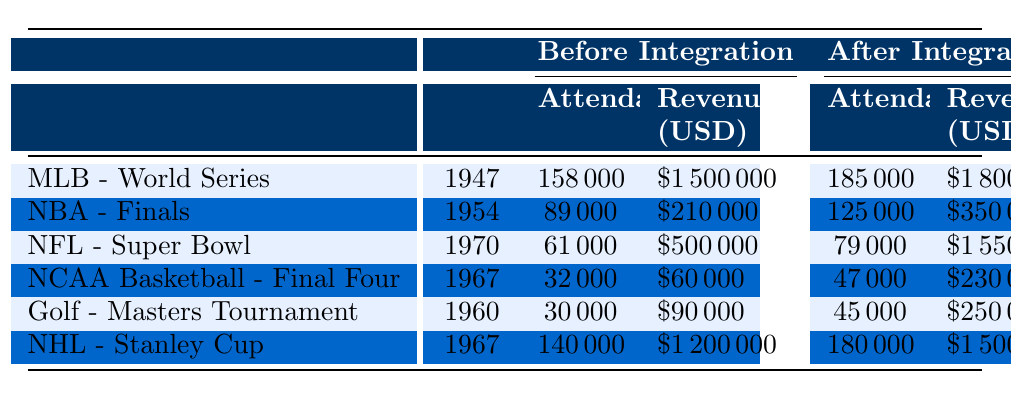What was the attendance at the MLB World Series in 1947? According to the table, the attendance at the MLB World Series in 1947 was listed under the "Before Integration" section, which shows a value of 158,000.
Answer: 158,000 How much revenue did the NBA Finals generate in 1954? The table indicates the revenue for the NBA Finals in 1954 under the "Before Integration" column, which is $210,000.
Answer: $210,000 Which sporting event had the highest attendance after integration? The table shows the attendance after integration for each event. The highest figure is found in the NHL Stanley Cup, with 180,000 attendees.
Answer: NHL Stanley Cup What was the difference in attendance for the NFL Super Bowl before and after integration? For the NFL Super Bowl, attendance before integration was 61,000 and after integration was 79,000. The difference is calculated as 79,000 - 61,000 = 18,000.
Answer: 18,000 Did NCAA Basketball - Final Four have an increase in revenue after integration? The revenue increased from $60,000 before integration to $230,000 after integration, so yes, there was an increase.
Answer: Yes What are the average attendances before and after integration across all events? Before integration: (158,000 + 89,000 + 61,000 + 32,000 + 30,000 + 140,000) / 6 = 83,333.33. After integration: (185,000 + 125,000 + 79,000 + 47,000 + 45,000 + 180,000) / 6 = 93,500. The averages are approximately 83,333 and 93,500, respectively.
Answer: Before: 83,333; After: 93,500 How much did the revenue increase for the MLB World Series after integration? The revenue for the MLB World Series before integration was $1,500,000 and after integration was $1,800,000. The increase is $1,800,000 - $1,500,000 = $300,000.
Answer: $300,000 Was the attendance at the Masters Tournament after integration more than that of the NCAA Division I Basketball Final Four after integration? The attendance for the Masters Tournament after integration was 45,000 while the NCAA Final Four had 47,000. Since 45,000 is less than 47,000, the attendance was not more.
Answer: No What was the total revenue generated by the NFL Super Bowl before integration? The table provides the revenue for the NFL Super Bowl before integration as $500,000, which is a direct retrieval from the data displayed.
Answer: $500,000 Which event had the largest percentage increase in attendance after integration? The percentage increases are calculated as follows: MLB: ((185,000 - 158,000) / 158,000) * 100 = 17.09%, NBA: ((125,000 - 89,000) / 89,000) * 100 = 40.45%, NFL: ((79,000 - 61,000) / 61,000) * 100 = 29.51%, NCAA: ((47,000 - 32,000) / 32,000) * 100 = 46.88%, Golf: ((45,000 - 30,000) / 30,000) * 100 = 50%, NHL: ((180,000 - 140,000) / 140,000) * 100 = 28.57%. The largest increase is 50% for the Masters Tournament.
Answer: Masters Tournament How does the total revenue of all events compare before and after integration? Summing before integration gives $1,500,000 + $210,000 + $500,000 + $60,000 + $90,000 + $1,200,000 = $3,560,000. After integration totals $1,800,000 + $350,000 + $1,550,000 + $230,000 + $250,000 + $1,500,000 = $5,680,000. The total revenue after integration is greater by $5,680,000 - $3,560,000 = $2,120,000.
Answer: $2,120,000 